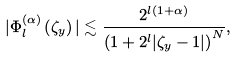<formula> <loc_0><loc_0><loc_500><loc_500>| \Phi _ { l } ^ { \left ( \alpha \right ) } \left ( \zeta _ { y } \right ) | \lesssim \frac { 2 ^ { l \left ( 1 + \alpha \right ) } } { \left ( 1 + 2 ^ { l } | \zeta _ { y } - 1 | \right ) ^ { N } } ,</formula> 